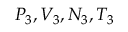Convert formula to latex. <formula><loc_0><loc_0><loc_500><loc_500>P _ { 3 } , V _ { 3 } , N _ { 3 } , T _ { 3 }</formula> 